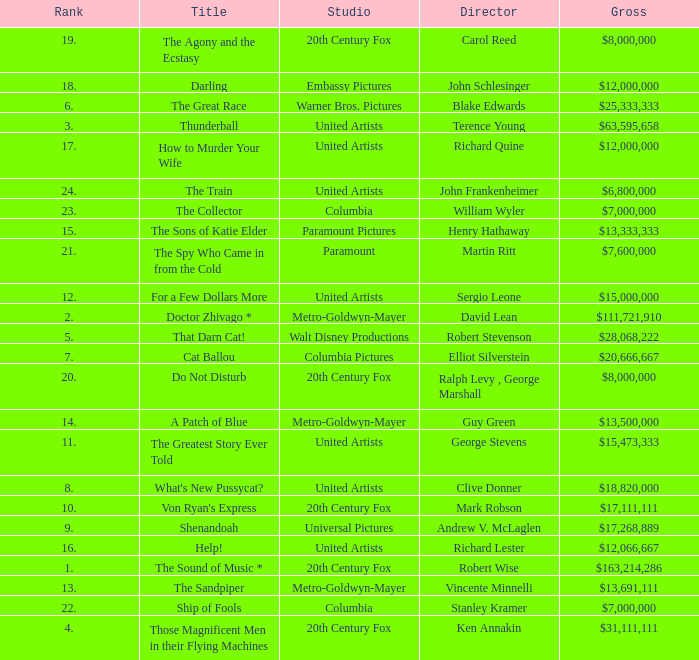What is Studio, when Title is "Do Not Disturb"? 20th Century Fox. 